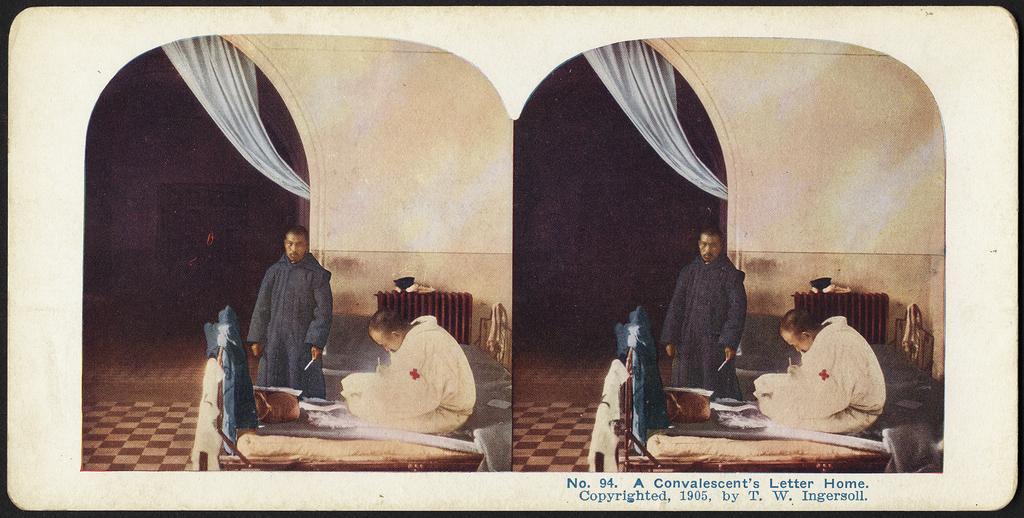In one or two sentences, can you explain what this image depicts? In this image there is a collage of the same images. In this image there is a man standing and on the bed there is another man sitting. And on the bed there are few items. In the background there is a table with an item, wall and a curtain. 